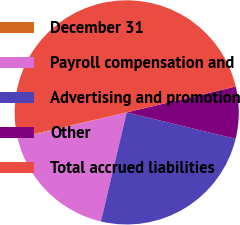Convert chart to OTSL. <chart><loc_0><loc_0><loc_500><loc_500><pie_chart><fcel>December 31<fcel>Payroll compensation and<fcel>Advertising and promotion<fcel>Other<fcel>Total accrued liabilities<nl><fcel>0.14%<fcel>17.53%<fcel>24.9%<fcel>7.5%<fcel>49.93%<nl></chart> 